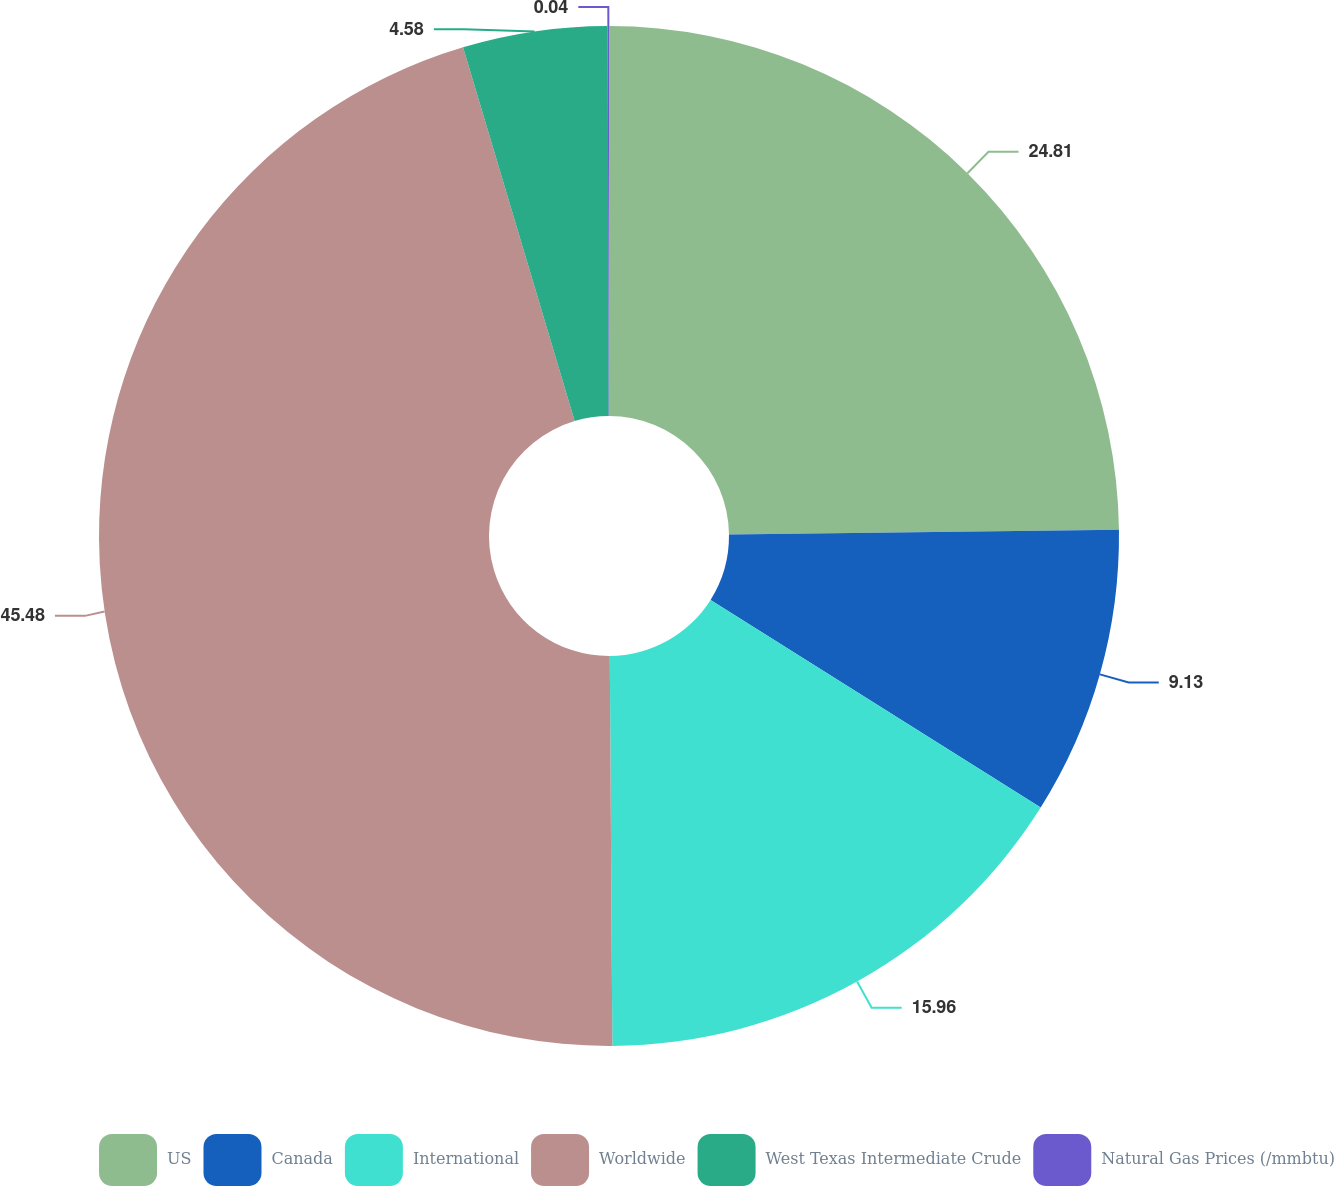Convert chart to OTSL. <chart><loc_0><loc_0><loc_500><loc_500><pie_chart><fcel>US<fcel>Canada<fcel>International<fcel>Worldwide<fcel>West Texas Intermediate Crude<fcel>Natural Gas Prices (/mmbtu)<nl><fcel>24.81%<fcel>9.13%<fcel>15.96%<fcel>45.49%<fcel>4.58%<fcel>0.04%<nl></chart> 